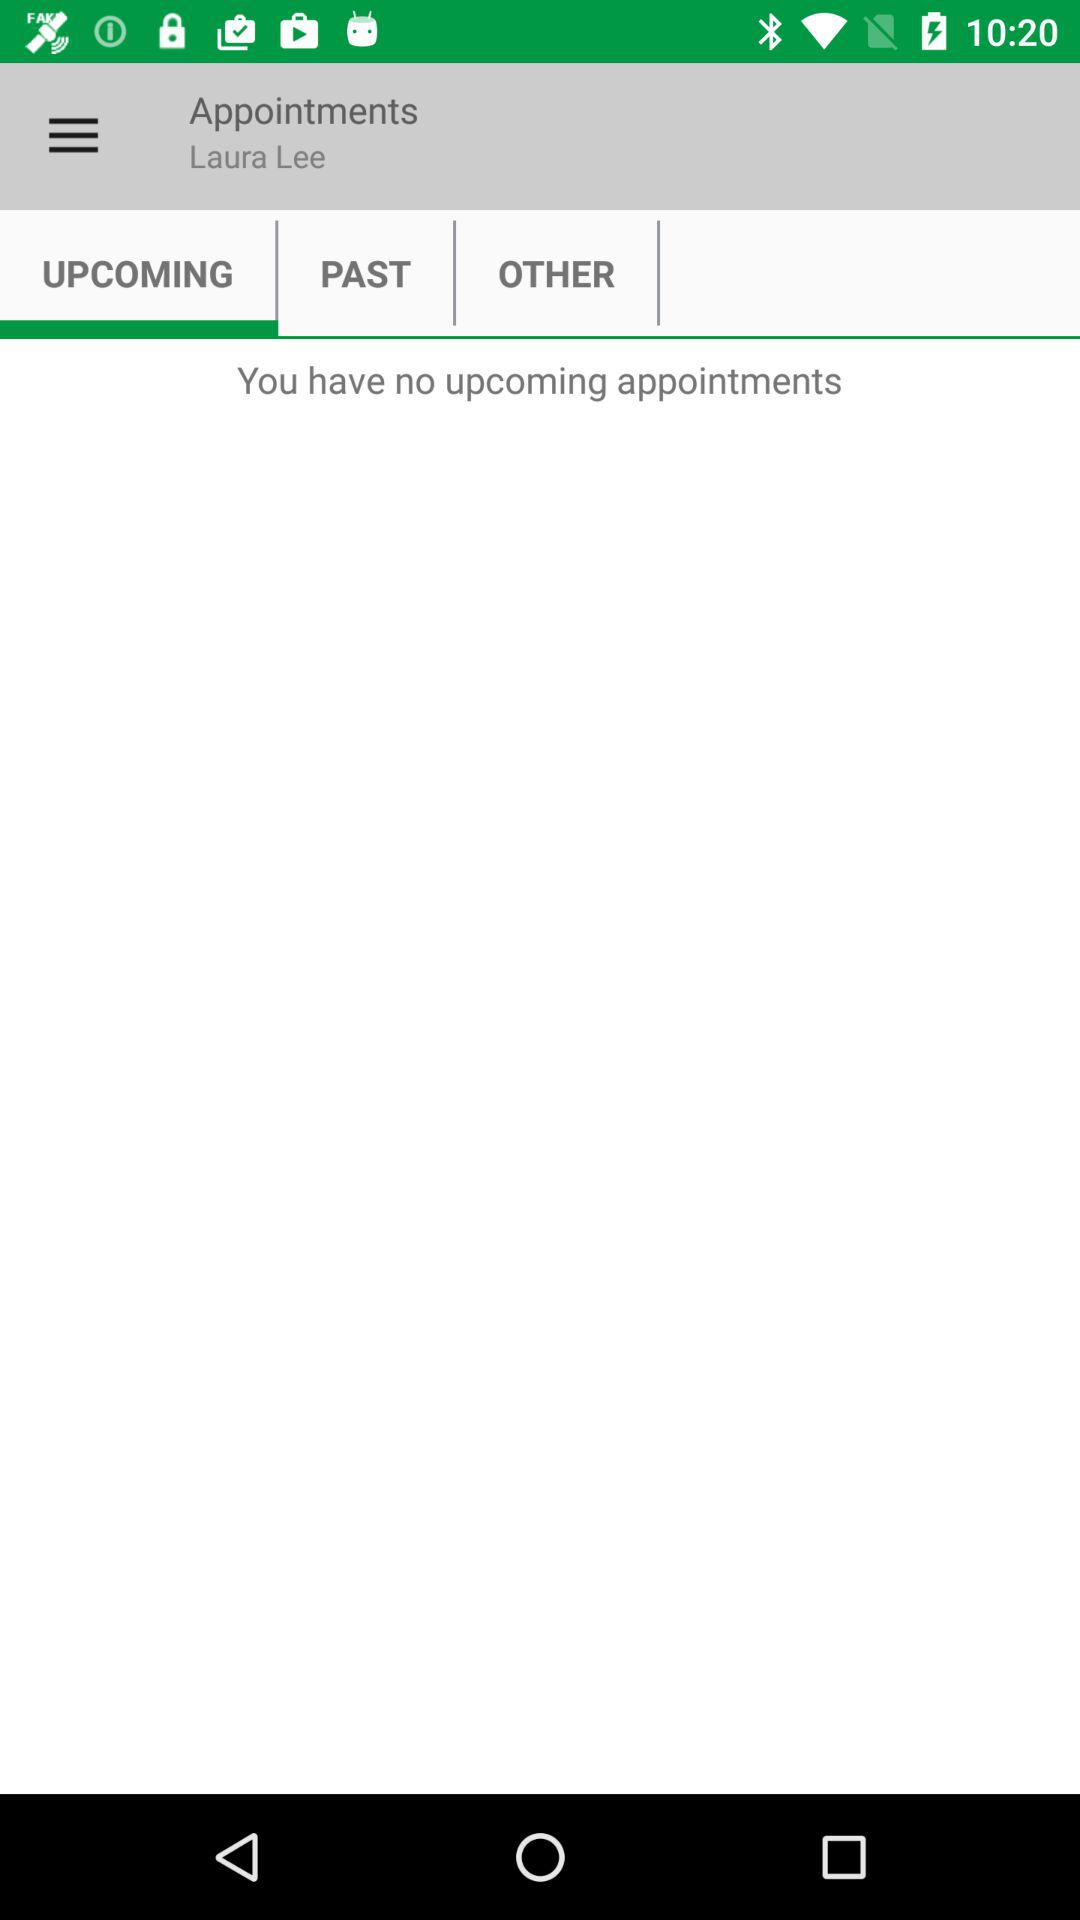How many appointments are there?
Answer the question using a single word or phrase. 0 